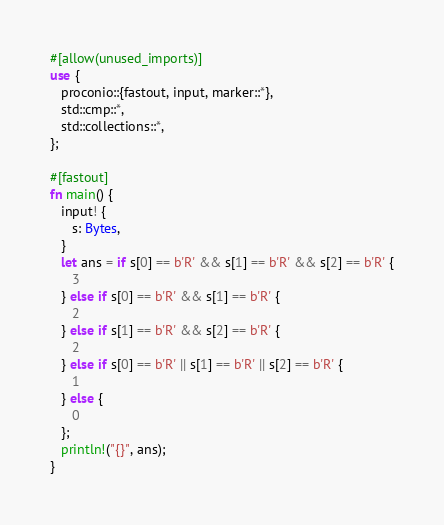<code> <loc_0><loc_0><loc_500><loc_500><_Rust_>#[allow(unused_imports)]
use {
   proconio::{fastout, input, marker::*},
   std::cmp::*,
   std::collections::*,
};

#[fastout]
fn main() {
   input! {
      s: Bytes,
   }
   let ans = if s[0] == b'R' && s[1] == b'R' && s[2] == b'R' {
      3
   } else if s[0] == b'R' && s[1] == b'R' {
      2
   } else if s[1] == b'R' && s[2] == b'R' {
      2
   } else if s[0] == b'R' || s[1] == b'R' || s[2] == b'R' {
      1
   } else {
      0
   };
   println!("{}", ans);
}
</code> 